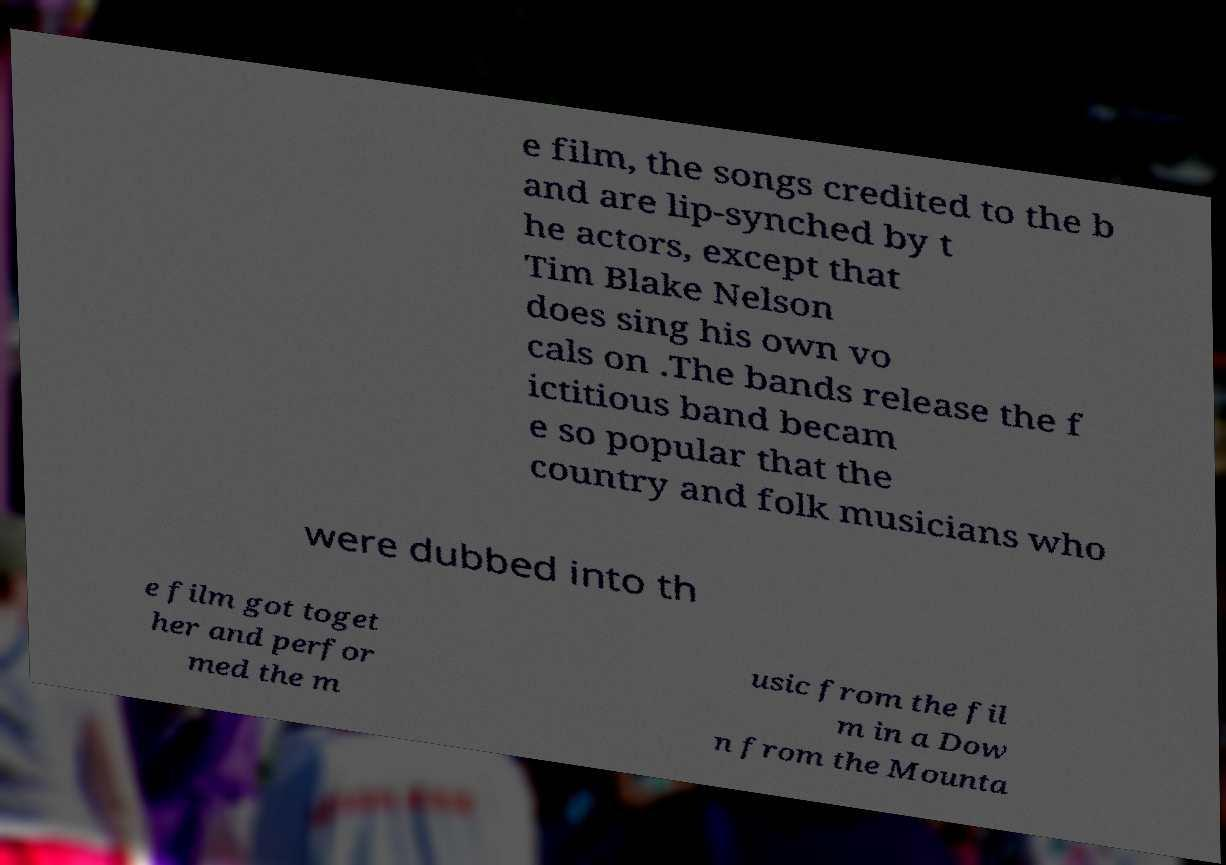There's text embedded in this image that I need extracted. Can you transcribe it verbatim? e film, the songs credited to the b and are lip-synched by t he actors, except that Tim Blake Nelson does sing his own vo cals on .The bands release the f ictitious band becam e so popular that the country and folk musicians who were dubbed into th e film got toget her and perfor med the m usic from the fil m in a Dow n from the Mounta 